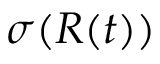Convert formula to latex. <formula><loc_0><loc_0><loc_500><loc_500>\sigma ( R ( t ) )</formula> 